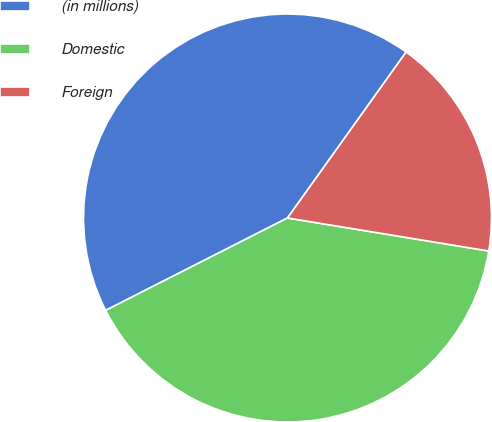Convert chart to OTSL. <chart><loc_0><loc_0><loc_500><loc_500><pie_chart><fcel>(in millions)<fcel>Domestic<fcel>Foreign<nl><fcel>42.36%<fcel>39.93%<fcel>17.71%<nl></chart> 